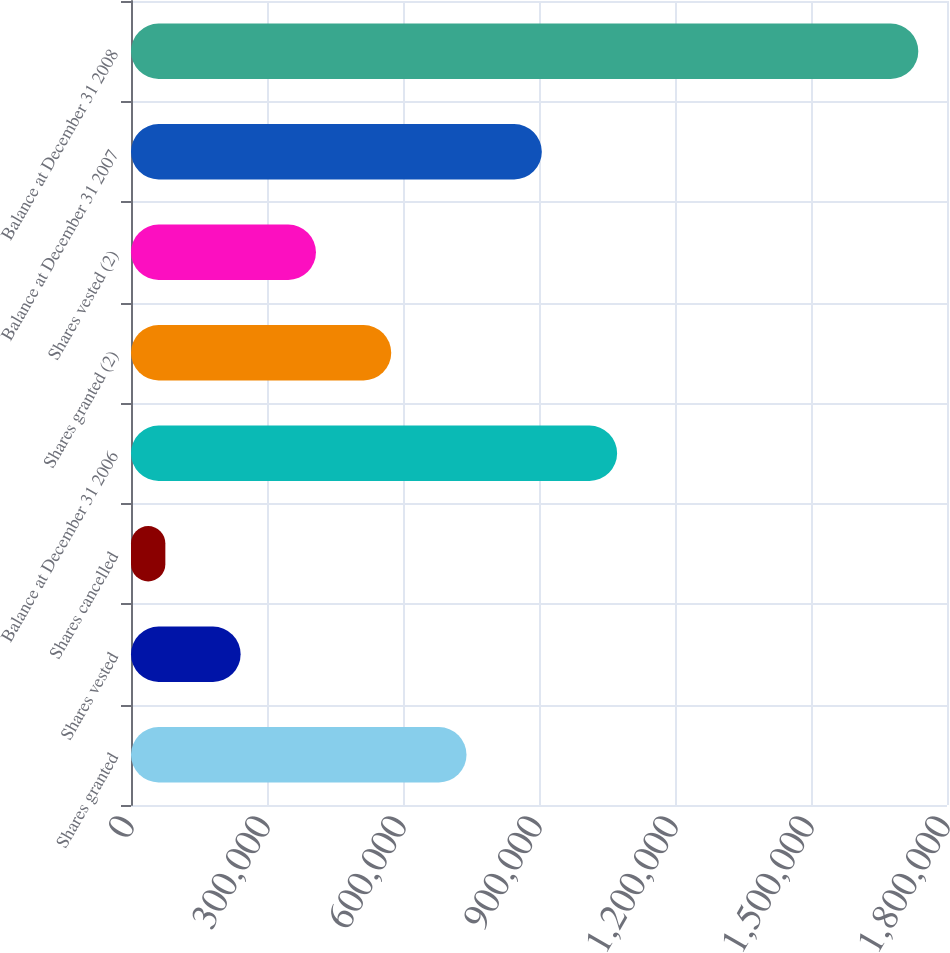Convert chart. <chart><loc_0><loc_0><loc_500><loc_500><bar_chart><fcel>Shares granted<fcel>Shares vested<fcel>Shares cancelled<fcel>Balance at December 31 2006<fcel>Shares granted (2)<fcel>Shares vested (2)<fcel>Balance at December 31 2007<fcel>Balance at December 31 2008<nl><fcel>740139<fcel>241858<fcel>75765<fcel>1.07233e+06<fcel>574046<fcel>407952<fcel>906232<fcel>1.7367e+06<nl></chart> 